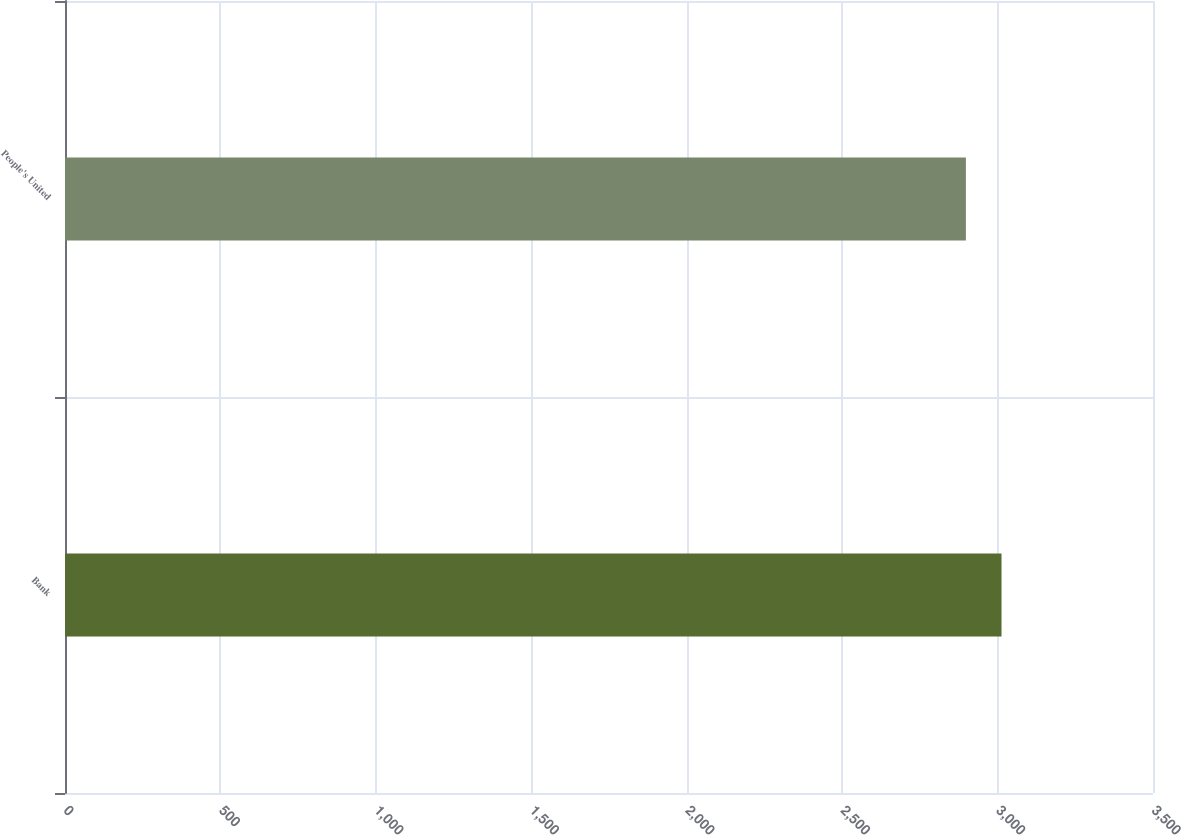Convert chart. <chart><loc_0><loc_0><loc_500><loc_500><bar_chart><fcel>Bank<fcel>People's United<nl><fcel>3012.7<fcel>2898.1<nl></chart> 